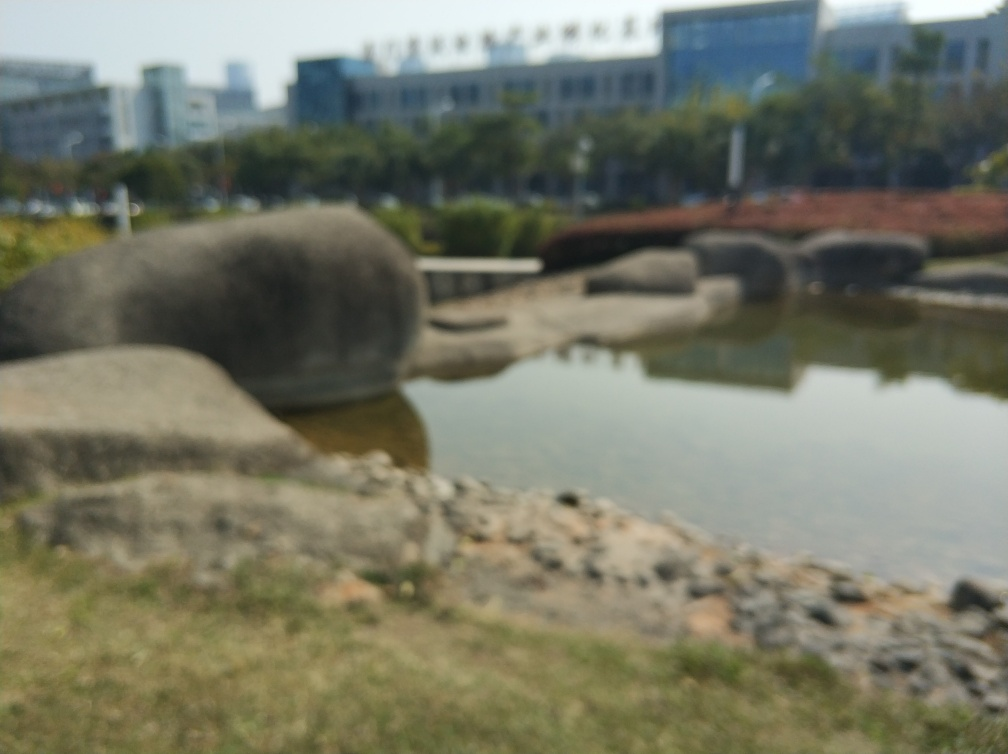Are there any distinguishing features that could hint at the location? The blurred elements make it challenging to identify specific landmarks or location-specific features. Nonetheless, we can observe some water and what appear to be rock formations, suggesting an outdoor setting, possibly a park or garden, with man-made elements like the bridge in the background. 